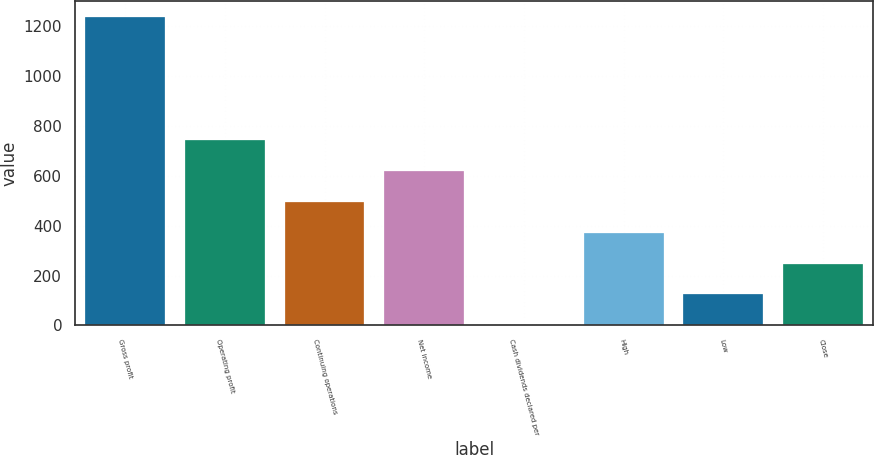Convert chart. <chart><loc_0><loc_0><loc_500><loc_500><bar_chart><fcel>Gross profit<fcel>Operating profit<fcel>Continuing operations<fcel>Net income<fcel>Cash dividends declared per<fcel>High<fcel>Low<fcel>Close<nl><fcel>1239.1<fcel>743.62<fcel>495.88<fcel>619.75<fcel>0.4<fcel>372.01<fcel>124.27<fcel>248.14<nl></chart> 